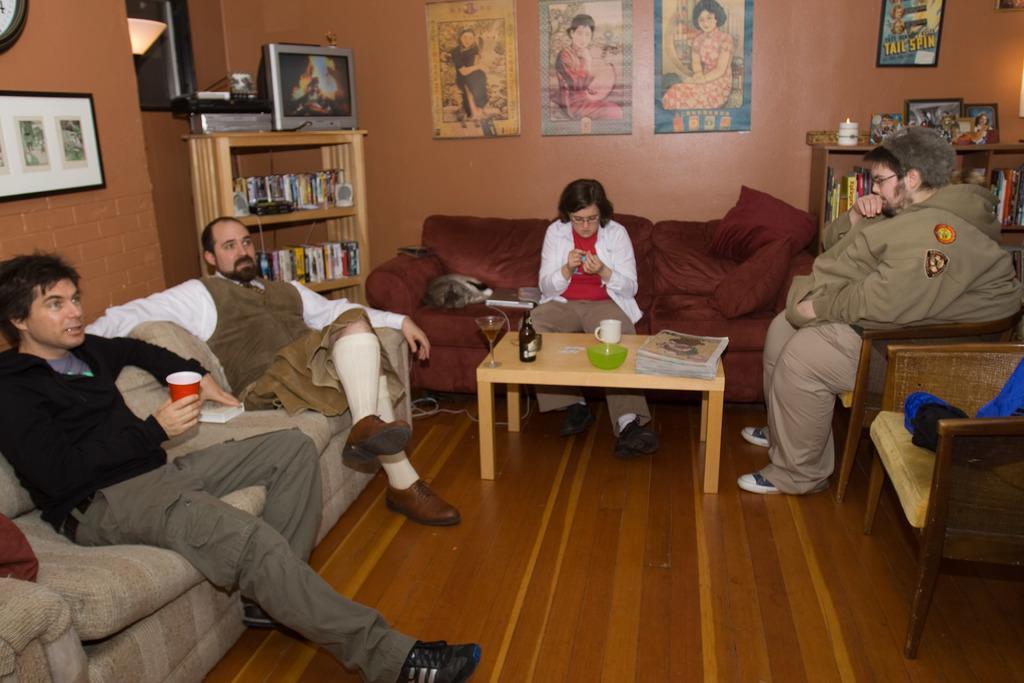Describe this image in one or two sentences. In this image, there are four people sitting in the sofas. In the background, there is a wall on which frames are fixed. To the left, the man sitting is wearing black shirt. To the right, the man is wearing brown jacket. In the middle, there is a red sofa. To the left, there is a cupboard, on which TV is kept. 